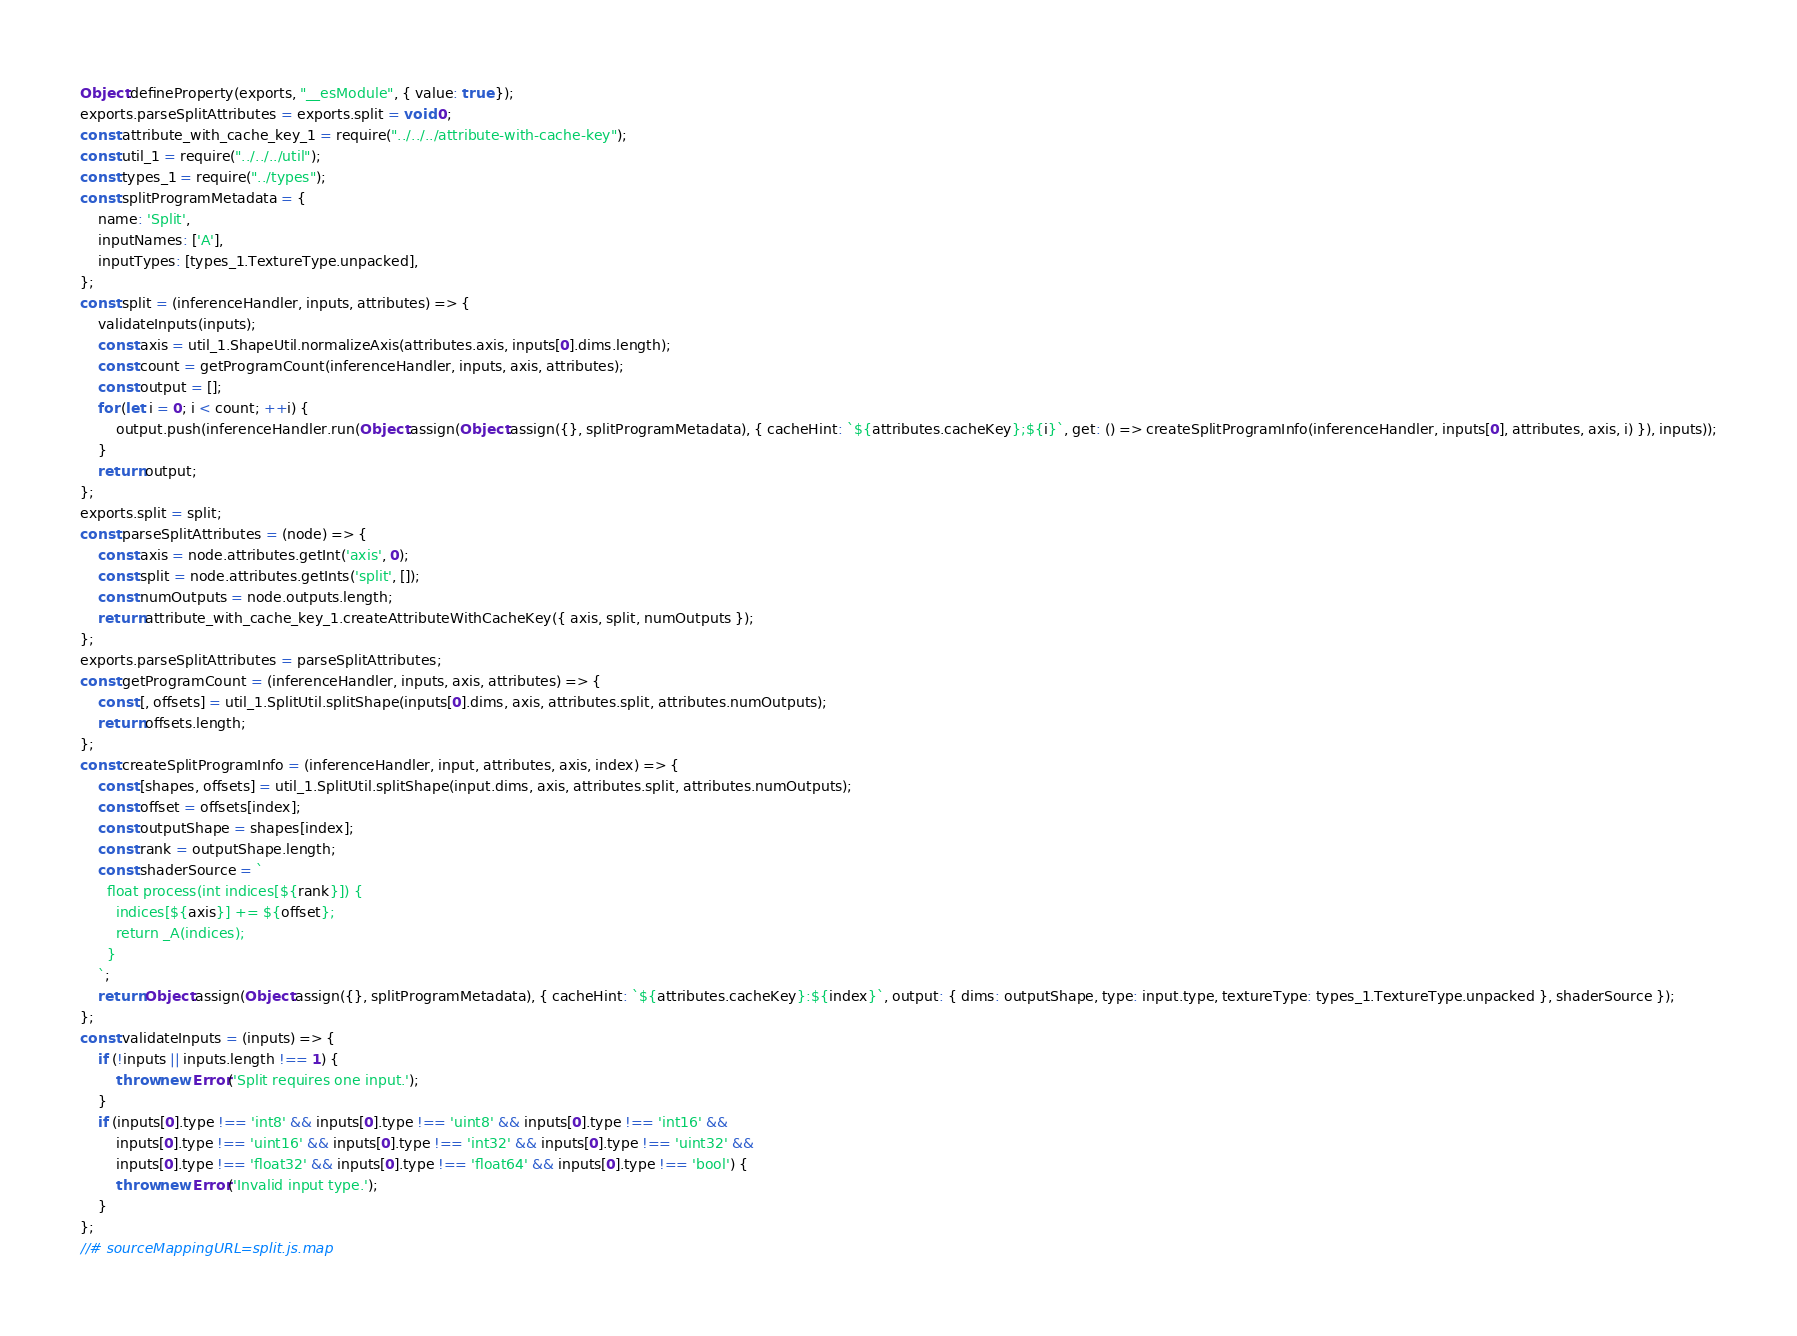<code> <loc_0><loc_0><loc_500><loc_500><_JavaScript_>Object.defineProperty(exports, "__esModule", { value: true });
exports.parseSplitAttributes = exports.split = void 0;
const attribute_with_cache_key_1 = require("../../../attribute-with-cache-key");
const util_1 = require("../../../util");
const types_1 = require("../types");
const splitProgramMetadata = {
    name: 'Split',
    inputNames: ['A'],
    inputTypes: [types_1.TextureType.unpacked],
};
const split = (inferenceHandler, inputs, attributes) => {
    validateInputs(inputs);
    const axis = util_1.ShapeUtil.normalizeAxis(attributes.axis, inputs[0].dims.length);
    const count = getProgramCount(inferenceHandler, inputs, axis, attributes);
    const output = [];
    for (let i = 0; i < count; ++i) {
        output.push(inferenceHandler.run(Object.assign(Object.assign({}, splitProgramMetadata), { cacheHint: `${attributes.cacheKey};${i}`, get: () => createSplitProgramInfo(inferenceHandler, inputs[0], attributes, axis, i) }), inputs));
    }
    return output;
};
exports.split = split;
const parseSplitAttributes = (node) => {
    const axis = node.attributes.getInt('axis', 0);
    const split = node.attributes.getInts('split', []);
    const numOutputs = node.outputs.length;
    return attribute_with_cache_key_1.createAttributeWithCacheKey({ axis, split, numOutputs });
};
exports.parseSplitAttributes = parseSplitAttributes;
const getProgramCount = (inferenceHandler, inputs, axis, attributes) => {
    const [, offsets] = util_1.SplitUtil.splitShape(inputs[0].dims, axis, attributes.split, attributes.numOutputs);
    return offsets.length;
};
const createSplitProgramInfo = (inferenceHandler, input, attributes, axis, index) => {
    const [shapes, offsets] = util_1.SplitUtil.splitShape(input.dims, axis, attributes.split, attributes.numOutputs);
    const offset = offsets[index];
    const outputShape = shapes[index];
    const rank = outputShape.length;
    const shaderSource = `
      float process(int indices[${rank}]) {
        indices[${axis}] += ${offset};
        return _A(indices);
      }
    `;
    return Object.assign(Object.assign({}, splitProgramMetadata), { cacheHint: `${attributes.cacheKey}:${index}`, output: { dims: outputShape, type: input.type, textureType: types_1.TextureType.unpacked }, shaderSource });
};
const validateInputs = (inputs) => {
    if (!inputs || inputs.length !== 1) {
        throw new Error('Split requires one input.');
    }
    if (inputs[0].type !== 'int8' && inputs[0].type !== 'uint8' && inputs[0].type !== 'int16' &&
        inputs[0].type !== 'uint16' && inputs[0].type !== 'int32' && inputs[0].type !== 'uint32' &&
        inputs[0].type !== 'float32' && inputs[0].type !== 'float64' && inputs[0].type !== 'bool') {
        throw new Error('Invalid input type.');
    }
};
//# sourceMappingURL=split.js.map</code> 